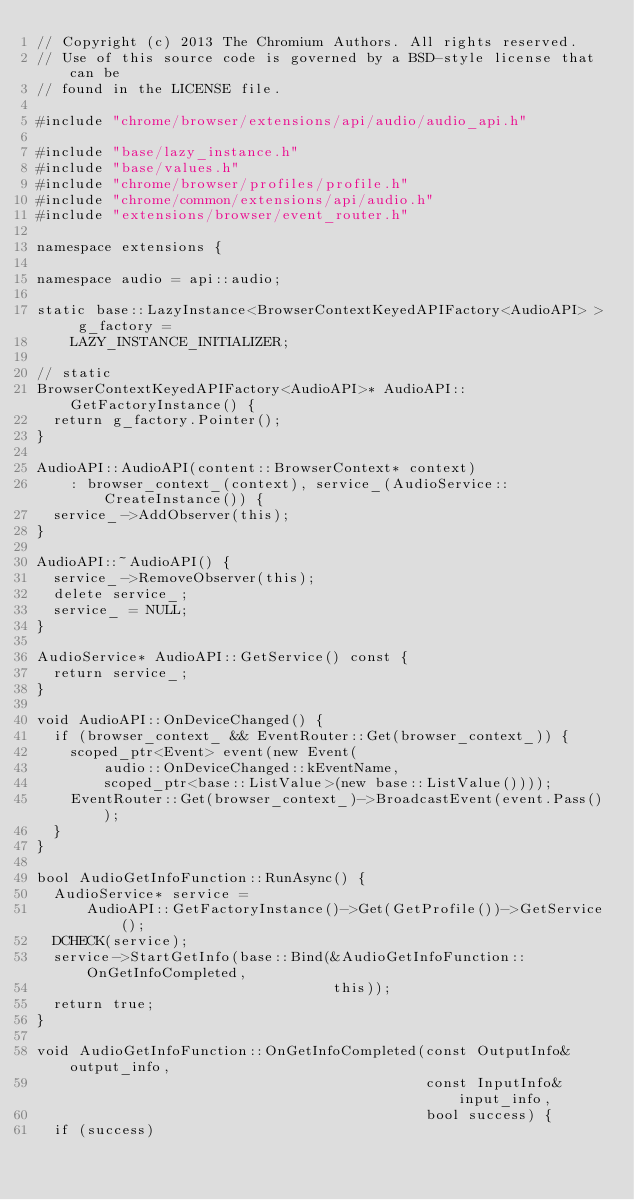<code> <loc_0><loc_0><loc_500><loc_500><_C++_>// Copyright (c) 2013 The Chromium Authors. All rights reserved.
// Use of this source code is governed by a BSD-style license that can be
// found in the LICENSE file.

#include "chrome/browser/extensions/api/audio/audio_api.h"

#include "base/lazy_instance.h"
#include "base/values.h"
#include "chrome/browser/profiles/profile.h"
#include "chrome/common/extensions/api/audio.h"
#include "extensions/browser/event_router.h"

namespace extensions {

namespace audio = api::audio;

static base::LazyInstance<BrowserContextKeyedAPIFactory<AudioAPI> > g_factory =
    LAZY_INSTANCE_INITIALIZER;

// static
BrowserContextKeyedAPIFactory<AudioAPI>* AudioAPI::GetFactoryInstance() {
  return g_factory.Pointer();
}

AudioAPI::AudioAPI(content::BrowserContext* context)
    : browser_context_(context), service_(AudioService::CreateInstance()) {
  service_->AddObserver(this);
}

AudioAPI::~AudioAPI() {
  service_->RemoveObserver(this);
  delete service_;
  service_ = NULL;
}

AudioService* AudioAPI::GetService() const {
  return service_;
}

void AudioAPI::OnDeviceChanged() {
  if (browser_context_ && EventRouter::Get(browser_context_)) {
    scoped_ptr<Event> event(new Event(
        audio::OnDeviceChanged::kEventName,
        scoped_ptr<base::ListValue>(new base::ListValue())));
    EventRouter::Get(browser_context_)->BroadcastEvent(event.Pass());
  }
}

bool AudioGetInfoFunction::RunAsync() {
  AudioService* service =
      AudioAPI::GetFactoryInstance()->Get(GetProfile())->GetService();
  DCHECK(service);
  service->StartGetInfo(base::Bind(&AudioGetInfoFunction::OnGetInfoCompleted,
                                   this));
  return true;
}

void AudioGetInfoFunction::OnGetInfoCompleted(const OutputInfo& output_info,
                                              const InputInfo& input_info,
                                              bool success) {
  if (success)</code> 